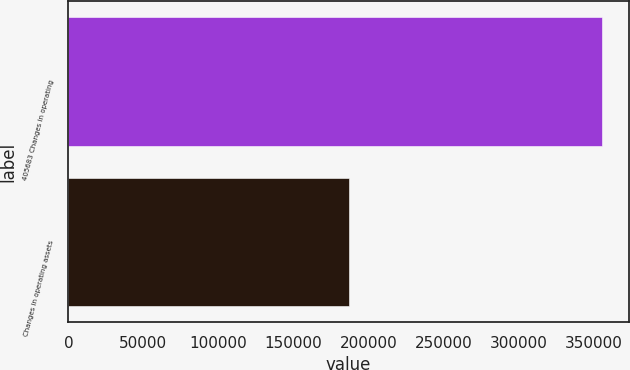<chart> <loc_0><loc_0><loc_500><loc_500><bar_chart><fcel>405683 Changes in operating<fcel>Changes in operating assets<nl><fcel>355464<fcel>186951<nl></chart> 